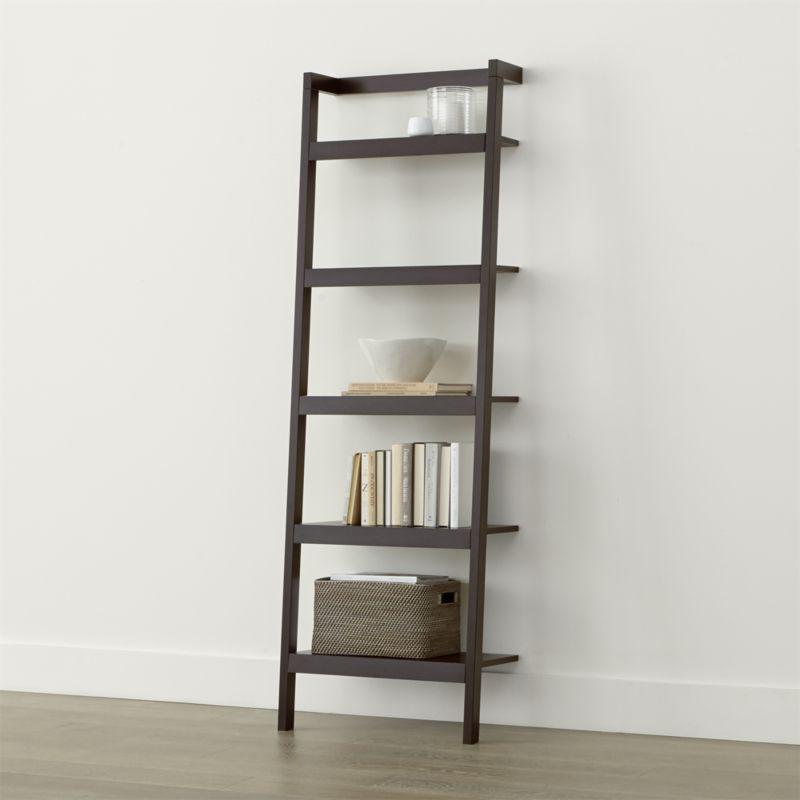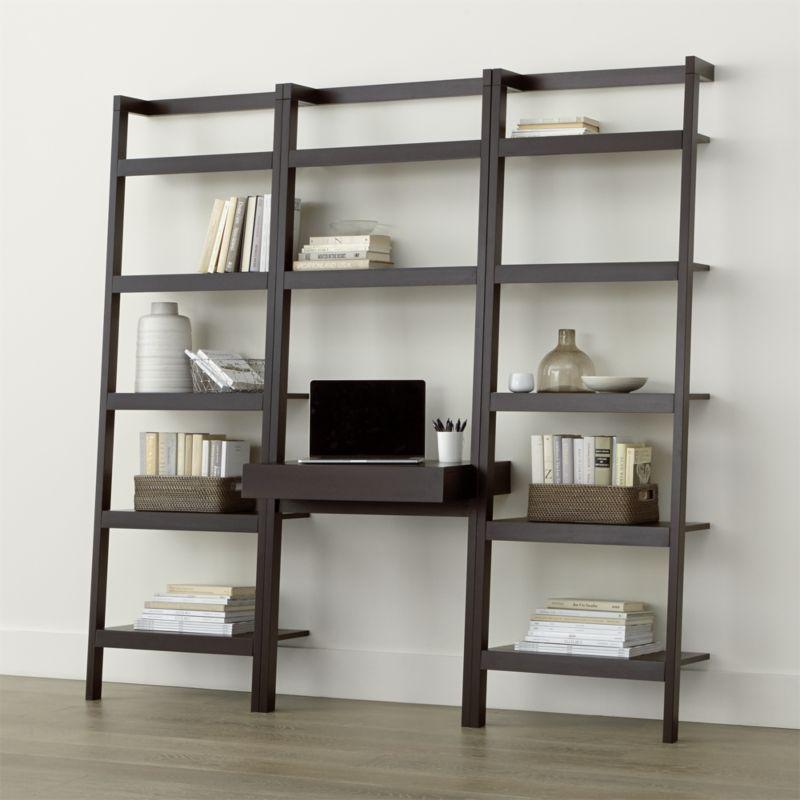The first image is the image on the left, the second image is the image on the right. Analyze the images presented: Is the assertion "One shelf has 3 columns, while the other one has only one." valid? Answer yes or no. Yes. 